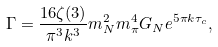Convert formula to latex. <formula><loc_0><loc_0><loc_500><loc_500>\Gamma = \frac { 1 6 \zeta ( 3 ) } { \pi ^ { 3 } k ^ { 3 } } m ^ { 2 } _ { N } m ^ { 4 } _ { \pi } G _ { N } e ^ { 5 \pi k \tau _ { c } } ,</formula> 